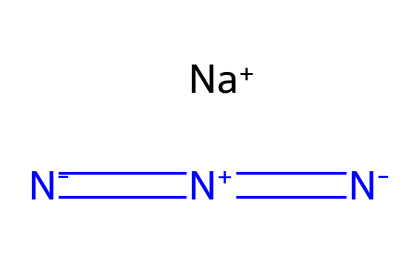What is the central atom in sodium azide? The SMILES representation indicates the presence of three nitrogen atoms surrounding one sodium atom. Sodium is the central atom bonded to the azide group.
Answer: sodium How many nitrogen atoms are present in sodium azide? Analyzing the SMILES shows three nitrogen atoms represented by '[N-]=[N+]=[N-]'. There are three connected nitrogen atoms in the structure.
Answer: three What type of bonds connect the nitrogen atoms in sodium azide? The nitrogen atoms are connected by double bonds as shown by the '=' symbols in the SMILES. This indicates multiple bonding between these nitrogen atoms.
Answer: double bonds What is the charge on the sodium ion in sodium azide? The 'Na+' in the SMILES indicates that the sodium ion carries a positive charge. Therefore, sodium is positively charged in this compound.
Answer: positive charge How does sodium azide decompose to produce nitrogen gas? Sodium azide decomposes upon heating, breaking down into sodium metal and nitrogen gas. This can be inferred from the azide's unstable nature due to the nitrogen-nitrogen bonds.
Answer: nitrogen gas What type of compound is sodium azide classified as? Sodium azide is classified as an azide. The 'azide' is a functional group present in the structure, characterized by its nitrogen linking.
Answer: azide 